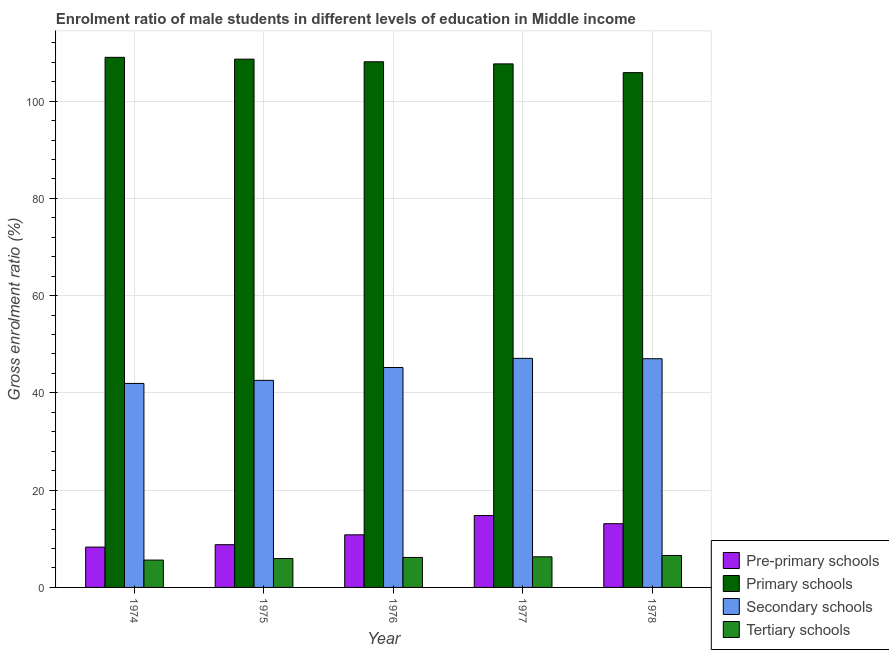How many different coloured bars are there?
Offer a very short reply. 4. How many groups of bars are there?
Provide a short and direct response. 5. Are the number of bars per tick equal to the number of legend labels?
Ensure brevity in your answer.  Yes. Are the number of bars on each tick of the X-axis equal?
Your response must be concise. Yes. How many bars are there on the 3rd tick from the left?
Make the answer very short. 4. How many bars are there on the 1st tick from the right?
Give a very brief answer. 4. What is the label of the 1st group of bars from the left?
Make the answer very short. 1974. In how many cases, is the number of bars for a given year not equal to the number of legend labels?
Your answer should be very brief. 0. What is the gross enrolment ratio(female) in primary schools in 1978?
Provide a succinct answer. 105.85. Across all years, what is the maximum gross enrolment ratio(female) in pre-primary schools?
Ensure brevity in your answer.  14.78. Across all years, what is the minimum gross enrolment ratio(female) in secondary schools?
Provide a short and direct response. 41.95. In which year was the gross enrolment ratio(female) in primary schools maximum?
Make the answer very short. 1974. In which year was the gross enrolment ratio(female) in primary schools minimum?
Your answer should be compact. 1978. What is the total gross enrolment ratio(female) in secondary schools in the graph?
Provide a succinct answer. 223.88. What is the difference between the gross enrolment ratio(female) in pre-primary schools in 1975 and that in 1977?
Make the answer very short. -5.99. What is the difference between the gross enrolment ratio(female) in secondary schools in 1976 and the gross enrolment ratio(female) in primary schools in 1978?
Provide a succinct answer. -1.81. What is the average gross enrolment ratio(female) in secondary schools per year?
Make the answer very short. 44.78. In the year 1976, what is the difference between the gross enrolment ratio(female) in secondary schools and gross enrolment ratio(female) in pre-primary schools?
Provide a short and direct response. 0. What is the ratio of the gross enrolment ratio(female) in tertiary schools in 1974 to that in 1977?
Offer a terse response. 0.89. Is the gross enrolment ratio(female) in secondary schools in 1974 less than that in 1978?
Make the answer very short. Yes. Is the difference between the gross enrolment ratio(female) in secondary schools in 1974 and 1976 greater than the difference between the gross enrolment ratio(female) in primary schools in 1974 and 1976?
Your answer should be very brief. No. What is the difference between the highest and the second highest gross enrolment ratio(female) in tertiary schools?
Keep it short and to the point. 0.28. What is the difference between the highest and the lowest gross enrolment ratio(female) in pre-primary schools?
Make the answer very short. 6.49. Is the sum of the gross enrolment ratio(female) in primary schools in 1974 and 1977 greater than the maximum gross enrolment ratio(female) in pre-primary schools across all years?
Offer a terse response. Yes. What does the 4th bar from the left in 1978 represents?
Provide a succinct answer. Tertiary schools. What does the 3rd bar from the right in 1978 represents?
Provide a succinct answer. Primary schools. Are all the bars in the graph horizontal?
Ensure brevity in your answer.  No. How many years are there in the graph?
Your answer should be very brief. 5. What is the difference between two consecutive major ticks on the Y-axis?
Provide a short and direct response. 20. Are the values on the major ticks of Y-axis written in scientific E-notation?
Provide a succinct answer. No. Does the graph contain grids?
Your answer should be compact. Yes. How are the legend labels stacked?
Your answer should be compact. Vertical. What is the title of the graph?
Your response must be concise. Enrolment ratio of male students in different levels of education in Middle income. Does "Terrestrial protected areas" appear as one of the legend labels in the graph?
Your answer should be very brief. No. What is the Gross enrolment ratio (%) in Pre-primary schools in 1974?
Keep it short and to the point. 8.29. What is the Gross enrolment ratio (%) in Primary schools in 1974?
Your response must be concise. 109. What is the Gross enrolment ratio (%) of Secondary schools in 1974?
Keep it short and to the point. 41.95. What is the Gross enrolment ratio (%) of Tertiary schools in 1974?
Offer a terse response. 5.62. What is the Gross enrolment ratio (%) in Pre-primary schools in 1975?
Ensure brevity in your answer.  8.79. What is the Gross enrolment ratio (%) in Primary schools in 1975?
Provide a succinct answer. 108.63. What is the Gross enrolment ratio (%) of Secondary schools in 1975?
Your response must be concise. 42.58. What is the Gross enrolment ratio (%) of Tertiary schools in 1975?
Provide a succinct answer. 5.94. What is the Gross enrolment ratio (%) in Pre-primary schools in 1976?
Provide a short and direct response. 10.82. What is the Gross enrolment ratio (%) in Primary schools in 1976?
Your answer should be very brief. 108.09. What is the Gross enrolment ratio (%) of Secondary schools in 1976?
Provide a short and direct response. 45.22. What is the Gross enrolment ratio (%) in Tertiary schools in 1976?
Your response must be concise. 6.17. What is the Gross enrolment ratio (%) in Pre-primary schools in 1977?
Offer a very short reply. 14.78. What is the Gross enrolment ratio (%) of Primary schools in 1977?
Offer a very short reply. 107.65. What is the Gross enrolment ratio (%) of Secondary schools in 1977?
Provide a succinct answer. 47.1. What is the Gross enrolment ratio (%) of Tertiary schools in 1977?
Your answer should be compact. 6.29. What is the Gross enrolment ratio (%) of Pre-primary schools in 1978?
Give a very brief answer. 13.1. What is the Gross enrolment ratio (%) in Primary schools in 1978?
Offer a terse response. 105.85. What is the Gross enrolment ratio (%) in Secondary schools in 1978?
Your answer should be compact. 47.03. What is the Gross enrolment ratio (%) in Tertiary schools in 1978?
Your answer should be very brief. 6.57. Across all years, what is the maximum Gross enrolment ratio (%) of Pre-primary schools?
Your answer should be compact. 14.78. Across all years, what is the maximum Gross enrolment ratio (%) in Primary schools?
Offer a terse response. 109. Across all years, what is the maximum Gross enrolment ratio (%) of Secondary schools?
Ensure brevity in your answer.  47.1. Across all years, what is the maximum Gross enrolment ratio (%) in Tertiary schools?
Make the answer very short. 6.57. Across all years, what is the minimum Gross enrolment ratio (%) of Pre-primary schools?
Make the answer very short. 8.29. Across all years, what is the minimum Gross enrolment ratio (%) in Primary schools?
Your answer should be compact. 105.85. Across all years, what is the minimum Gross enrolment ratio (%) in Secondary schools?
Your response must be concise. 41.95. Across all years, what is the minimum Gross enrolment ratio (%) of Tertiary schools?
Keep it short and to the point. 5.62. What is the total Gross enrolment ratio (%) of Pre-primary schools in the graph?
Your answer should be very brief. 55.79. What is the total Gross enrolment ratio (%) in Primary schools in the graph?
Provide a succinct answer. 539.21. What is the total Gross enrolment ratio (%) of Secondary schools in the graph?
Keep it short and to the point. 223.88. What is the total Gross enrolment ratio (%) in Tertiary schools in the graph?
Your answer should be compact. 30.6. What is the difference between the Gross enrolment ratio (%) in Pre-primary schools in 1974 and that in 1975?
Your answer should be very brief. -0.5. What is the difference between the Gross enrolment ratio (%) of Primary schools in 1974 and that in 1975?
Offer a terse response. 0.37. What is the difference between the Gross enrolment ratio (%) of Secondary schools in 1974 and that in 1975?
Your answer should be very brief. -0.63. What is the difference between the Gross enrolment ratio (%) in Tertiary schools in 1974 and that in 1975?
Offer a very short reply. -0.32. What is the difference between the Gross enrolment ratio (%) in Pre-primary schools in 1974 and that in 1976?
Ensure brevity in your answer.  -2.52. What is the difference between the Gross enrolment ratio (%) of Primary schools in 1974 and that in 1976?
Give a very brief answer. 0.91. What is the difference between the Gross enrolment ratio (%) of Secondary schools in 1974 and that in 1976?
Keep it short and to the point. -3.28. What is the difference between the Gross enrolment ratio (%) in Tertiary schools in 1974 and that in 1976?
Offer a terse response. -0.54. What is the difference between the Gross enrolment ratio (%) of Pre-primary schools in 1974 and that in 1977?
Provide a succinct answer. -6.49. What is the difference between the Gross enrolment ratio (%) in Primary schools in 1974 and that in 1977?
Your answer should be compact. 1.35. What is the difference between the Gross enrolment ratio (%) in Secondary schools in 1974 and that in 1977?
Your answer should be compact. -5.16. What is the difference between the Gross enrolment ratio (%) in Tertiary schools in 1974 and that in 1977?
Keep it short and to the point. -0.67. What is the difference between the Gross enrolment ratio (%) in Pre-primary schools in 1974 and that in 1978?
Your answer should be very brief. -4.81. What is the difference between the Gross enrolment ratio (%) in Primary schools in 1974 and that in 1978?
Provide a short and direct response. 3.15. What is the difference between the Gross enrolment ratio (%) in Secondary schools in 1974 and that in 1978?
Give a very brief answer. -5.08. What is the difference between the Gross enrolment ratio (%) in Tertiary schools in 1974 and that in 1978?
Give a very brief answer. -0.95. What is the difference between the Gross enrolment ratio (%) of Pre-primary schools in 1975 and that in 1976?
Offer a very short reply. -2.03. What is the difference between the Gross enrolment ratio (%) in Primary schools in 1975 and that in 1976?
Ensure brevity in your answer.  0.54. What is the difference between the Gross enrolment ratio (%) of Secondary schools in 1975 and that in 1976?
Give a very brief answer. -2.64. What is the difference between the Gross enrolment ratio (%) of Tertiary schools in 1975 and that in 1976?
Provide a succinct answer. -0.23. What is the difference between the Gross enrolment ratio (%) of Pre-primary schools in 1975 and that in 1977?
Offer a very short reply. -5.99. What is the difference between the Gross enrolment ratio (%) in Primary schools in 1975 and that in 1977?
Your answer should be compact. 0.97. What is the difference between the Gross enrolment ratio (%) of Secondary schools in 1975 and that in 1977?
Offer a terse response. -4.52. What is the difference between the Gross enrolment ratio (%) in Tertiary schools in 1975 and that in 1977?
Your answer should be compact. -0.36. What is the difference between the Gross enrolment ratio (%) of Pre-primary schools in 1975 and that in 1978?
Keep it short and to the point. -4.31. What is the difference between the Gross enrolment ratio (%) of Primary schools in 1975 and that in 1978?
Your answer should be compact. 2.78. What is the difference between the Gross enrolment ratio (%) in Secondary schools in 1975 and that in 1978?
Offer a very short reply. -4.45. What is the difference between the Gross enrolment ratio (%) of Tertiary schools in 1975 and that in 1978?
Provide a short and direct response. -0.63. What is the difference between the Gross enrolment ratio (%) in Pre-primary schools in 1976 and that in 1977?
Provide a short and direct response. -3.97. What is the difference between the Gross enrolment ratio (%) of Primary schools in 1976 and that in 1977?
Your answer should be very brief. 0.43. What is the difference between the Gross enrolment ratio (%) in Secondary schools in 1976 and that in 1977?
Give a very brief answer. -1.88. What is the difference between the Gross enrolment ratio (%) in Tertiary schools in 1976 and that in 1977?
Your response must be concise. -0.13. What is the difference between the Gross enrolment ratio (%) in Pre-primary schools in 1976 and that in 1978?
Provide a short and direct response. -2.28. What is the difference between the Gross enrolment ratio (%) in Primary schools in 1976 and that in 1978?
Provide a succinct answer. 2.23. What is the difference between the Gross enrolment ratio (%) in Secondary schools in 1976 and that in 1978?
Offer a terse response. -1.81. What is the difference between the Gross enrolment ratio (%) in Tertiary schools in 1976 and that in 1978?
Your answer should be compact. -0.41. What is the difference between the Gross enrolment ratio (%) in Pre-primary schools in 1977 and that in 1978?
Provide a short and direct response. 1.68. What is the difference between the Gross enrolment ratio (%) of Primary schools in 1977 and that in 1978?
Offer a very short reply. 1.8. What is the difference between the Gross enrolment ratio (%) of Secondary schools in 1977 and that in 1978?
Offer a terse response. 0.08. What is the difference between the Gross enrolment ratio (%) of Tertiary schools in 1977 and that in 1978?
Provide a succinct answer. -0.28. What is the difference between the Gross enrolment ratio (%) of Pre-primary schools in 1974 and the Gross enrolment ratio (%) of Primary schools in 1975?
Make the answer very short. -100.33. What is the difference between the Gross enrolment ratio (%) of Pre-primary schools in 1974 and the Gross enrolment ratio (%) of Secondary schools in 1975?
Provide a succinct answer. -34.29. What is the difference between the Gross enrolment ratio (%) in Pre-primary schools in 1974 and the Gross enrolment ratio (%) in Tertiary schools in 1975?
Ensure brevity in your answer.  2.35. What is the difference between the Gross enrolment ratio (%) of Primary schools in 1974 and the Gross enrolment ratio (%) of Secondary schools in 1975?
Make the answer very short. 66.42. What is the difference between the Gross enrolment ratio (%) of Primary schools in 1974 and the Gross enrolment ratio (%) of Tertiary schools in 1975?
Your answer should be compact. 103.06. What is the difference between the Gross enrolment ratio (%) of Secondary schools in 1974 and the Gross enrolment ratio (%) of Tertiary schools in 1975?
Your answer should be very brief. 36.01. What is the difference between the Gross enrolment ratio (%) of Pre-primary schools in 1974 and the Gross enrolment ratio (%) of Primary schools in 1976?
Offer a terse response. -99.79. What is the difference between the Gross enrolment ratio (%) of Pre-primary schools in 1974 and the Gross enrolment ratio (%) of Secondary schools in 1976?
Provide a short and direct response. -36.93. What is the difference between the Gross enrolment ratio (%) in Pre-primary schools in 1974 and the Gross enrolment ratio (%) in Tertiary schools in 1976?
Offer a very short reply. 2.13. What is the difference between the Gross enrolment ratio (%) of Primary schools in 1974 and the Gross enrolment ratio (%) of Secondary schools in 1976?
Make the answer very short. 63.78. What is the difference between the Gross enrolment ratio (%) of Primary schools in 1974 and the Gross enrolment ratio (%) of Tertiary schools in 1976?
Provide a short and direct response. 102.83. What is the difference between the Gross enrolment ratio (%) of Secondary schools in 1974 and the Gross enrolment ratio (%) of Tertiary schools in 1976?
Provide a succinct answer. 35.78. What is the difference between the Gross enrolment ratio (%) of Pre-primary schools in 1974 and the Gross enrolment ratio (%) of Primary schools in 1977?
Your response must be concise. -99.36. What is the difference between the Gross enrolment ratio (%) in Pre-primary schools in 1974 and the Gross enrolment ratio (%) in Secondary schools in 1977?
Ensure brevity in your answer.  -38.81. What is the difference between the Gross enrolment ratio (%) in Pre-primary schools in 1974 and the Gross enrolment ratio (%) in Tertiary schools in 1977?
Offer a terse response. 2. What is the difference between the Gross enrolment ratio (%) of Primary schools in 1974 and the Gross enrolment ratio (%) of Secondary schools in 1977?
Your response must be concise. 61.9. What is the difference between the Gross enrolment ratio (%) of Primary schools in 1974 and the Gross enrolment ratio (%) of Tertiary schools in 1977?
Provide a succinct answer. 102.71. What is the difference between the Gross enrolment ratio (%) in Secondary schools in 1974 and the Gross enrolment ratio (%) in Tertiary schools in 1977?
Provide a succinct answer. 35.65. What is the difference between the Gross enrolment ratio (%) of Pre-primary schools in 1974 and the Gross enrolment ratio (%) of Primary schools in 1978?
Give a very brief answer. -97.56. What is the difference between the Gross enrolment ratio (%) in Pre-primary schools in 1974 and the Gross enrolment ratio (%) in Secondary schools in 1978?
Keep it short and to the point. -38.73. What is the difference between the Gross enrolment ratio (%) in Pre-primary schools in 1974 and the Gross enrolment ratio (%) in Tertiary schools in 1978?
Provide a succinct answer. 1.72. What is the difference between the Gross enrolment ratio (%) of Primary schools in 1974 and the Gross enrolment ratio (%) of Secondary schools in 1978?
Your answer should be very brief. 61.97. What is the difference between the Gross enrolment ratio (%) of Primary schools in 1974 and the Gross enrolment ratio (%) of Tertiary schools in 1978?
Your answer should be very brief. 102.43. What is the difference between the Gross enrolment ratio (%) in Secondary schools in 1974 and the Gross enrolment ratio (%) in Tertiary schools in 1978?
Your answer should be compact. 35.37. What is the difference between the Gross enrolment ratio (%) in Pre-primary schools in 1975 and the Gross enrolment ratio (%) in Primary schools in 1976?
Ensure brevity in your answer.  -99.29. What is the difference between the Gross enrolment ratio (%) in Pre-primary schools in 1975 and the Gross enrolment ratio (%) in Secondary schools in 1976?
Give a very brief answer. -36.43. What is the difference between the Gross enrolment ratio (%) of Pre-primary schools in 1975 and the Gross enrolment ratio (%) of Tertiary schools in 1976?
Give a very brief answer. 2.62. What is the difference between the Gross enrolment ratio (%) in Primary schools in 1975 and the Gross enrolment ratio (%) in Secondary schools in 1976?
Your response must be concise. 63.41. What is the difference between the Gross enrolment ratio (%) in Primary schools in 1975 and the Gross enrolment ratio (%) in Tertiary schools in 1976?
Provide a short and direct response. 102.46. What is the difference between the Gross enrolment ratio (%) of Secondary schools in 1975 and the Gross enrolment ratio (%) of Tertiary schools in 1976?
Keep it short and to the point. 36.41. What is the difference between the Gross enrolment ratio (%) of Pre-primary schools in 1975 and the Gross enrolment ratio (%) of Primary schools in 1977?
Provide a short and direct response. -98.86. What is the difference between the Gross enrolment ratio (%) in Pre-primary schools in 1975 and the Gross enrolment ratio (%) in Secondary schools in 1977?
Ensure brevity in your answer.  -38.31. What is the difference between the Gross enrolment ratio (%) in Pre-primary schools in 1975 and the Gross enrolment ratio (%) in Tertiary schools in 1977?
Provide a short and direct response. 2.5. What is the difference between the Gross enrolment ratio (%) of Primary schools in 1975 and the Gross enrolment ratio (%) of Secondary schools in 1977?
Your answer should be compact. 61.52. What is the difference between the Gross enrolment ratio (%) of Primary schools in 1975 and the Gross enrolment ratio (%) of Tertiary schools in 1977?
Your response must be concise. 102.33. What is the difference between the Gross enrolment ratio (%) in Secondary schools in 1975 and the Gross enrolment ratio (%) in Tertiary schools in 1977?
Provide a succinct answer. 36.29. What is the difference between the Gross enrolment ratio (%) of Pre-primary schools in 1975 and the Gross enrolment ratio (%) of Primary schools in 1978?
Keep it short and to the point. -97.06. What is the difference between the Gross enrolment ratio (%) in Pre-primary schools in 1975 and the Gross enrolment ratio (%) in Secondary schools in 1978?
Ensure brevity in your answer.  -38.24. What is the difference between the Gross enrolment ratio (%) of Pre-primary schools in 1975 and the Gross enrolment ratio (%) of Tertiary schools in 1978?
Offer a very short reply. 2.22. What is the difference between the Gross enrolment ratio (%) in Primary schools in 1975 and the Gross enrolment ratio (%) in Secondary schools in 1978?
Provide a succinct answer. 61.6. What is the difference between the Gross enrolment ratio (%) of Primary schools in 1975 and the Gross enrolment ratio (%) of Tertiary schools in 1978?
Provide a short and direct response. 102.05. What is the difference between the Gross enrolment ratio (%) in Secondary schools in 1975 and the Gross enrolment ratio (%) in Tertiary schools in 1978?
Ensure brevity in your answer.  36.01. What is the difference between the Gross enrolment ratio (%) in Pre-primary schools in 1976 and the Gross enrolment ratio (%) in Primary schools in 1977?
Provide a succinct answer. -96.83. What is the difference between the Gross enrolment ratio (%) in Pre-primary schools in 1976 and the Gross enrolment ratio (%) in Secondary schools in 1977?
Give a very brief answer. -36.29. What is the difference between the Gross enrolment ratio (%) of Pre-primary schools in 1976 and the Gross enrolment ratio (%) of Tertiary schools in 1977?
Ensure brevity in your answer.  4.52. What is the difference between the Gross enrolment ratio (%) in Primary schools in 1976 and the Gross enrolment ratio (%) in Secondary schools in 1977?
Keep it short and to the point. 60.98. What is the difference between the Gross enrolment ratio (%) in Primary schools in 1976 and the Gross enrolment ratio (%) in Tertiary schools in 1977?
Offer a terse response. 101.79. What is the difference between the Gross enrolment ratio (%) of Secondary schools in 1976 and the Gross enrolment ratio (%) of Tertiary schools in 1977?
Provide a short and direct response. 38.93. What is the difference between the Gross enrolment ratio (%) of Pre-primary schools in 1976 and the Gross enrolment ratio (%) of Primary schools in 1978?
Offer a terse response. -95.03. What is the difference between the Gross enrolment ratio (%) of Pre-primary schools in 1976 and the Gross enrolment ratio (%) of Secondary schools in 1978?
Keep it short and to the point. -36.21. What is the difference between the Gross enrolment ratio (%) of Pre-primary schools in 1976 and the Gross enrolment ratio (%) of Tertiary schools in 1978?
Your answer should be very brief. 4.24. What is the difference between the Gross enrolment ratio (%) in Primary schools in 1976 and the Gross enrolment ratio (%) in Secondary schools in 1978?
Your answer should be compact. 61.06. What is the difference between the Gross enrolment ratio (%) of Primary schools in 1976 and the Gross enrolment ratio (%) of Tertiary schools in 1978?
Make the answer very short. 101.51. What is the difference between the Gross enrolment ratio (%) in Secondary schools in 1976 and the Gross enrolment ratio (%) in Tertiary schools in 1978?
Your answer should be compact. 38.65. What is the difference between the Gross enrolment ratio (%) in Pre-primary schools in 1977 and the Gross enrolment ratio (%) in Primary schools in 1978?
Offer a terse response. -91.07. What is the difference between the Gross enrolment ratio (%) of Pre-primary schools in 1977 and the Gross enrolment ratio (%) of Secondary schools in 1978?
Offer a terse response. -32.24. What is the difference between the Gross enrolment ratio (%) of Pre-primary schools in 1977 and the Gross enrolment ratio (%) of Tertiary schools in 1978?
Your answer should be compact. 8.21. What is the difference between the Gross enrolment ratio (%) in Primary schools in 1977 and the Gross enrolment ratio (%) in Secondary schools in 1978?
Keep it short and to the point. 60.63. What is the difference between the Gross enrolment ratio (%) in Primary schools in 1977 and the Gross enrolment ratio (%) in Tertiary schools in 1978?
Provide a short and direct response. 101.08. What is the difference between the Gross enrolment ratio (%) of Secondary schools in 1977 and the Gross enrolment ratio (%) of Tertiary schools in 1978?
Offer a terse response. 40.53. What is the average Gross enrolment ratio (%) in Pre-primary schools per year?
Offer a very short reply. 11.16. What is the average Gross enrolment ratio (%) of Primary schools per year?
Keep it short and to the point. 107.84. What is the average Gross enrolment ratio (%) of Secondary schools per year?
Ensure brevity in your answer.  44.78. What is the average Gross enrolment ratio (%) in Tertiary schools per year?
Provide a short and direct response. 6.12. In the year 1974, what is the difference between the Gross enrolment ratio (%) in Pre-primary schools and Gross enrolment ratio (%) in Primary schools?
Your answer should be compact. -100.71. In the year 1974, what is the difference between the Gross enrolment ratio (%) of Pre-primary schools and Gross enrolment ratio (%) of Secondary schools?
Keep it short and to the point. -33.65. In the year 1974, what is the difference between the Gross enrolment ratio (%) in Pre-primary schools and Gross enrolment ratio (%) in Tertiary schools?
Make the answer very short. 2.67. In the year 1974, what is the difference between the Gross enrolment ratio (%) of Primary schools and Gross enrolment ratio (%) of Secondary schools?
Provide a succinct answer. 67.05. In the year 1974, what is the difference between the Gross enrolment ratio (%) of Primary schools and Gross enrolment ratio (%) of Tertiary schools?
Make the answer very short. 103.38. In the year 1974, what is the difference between the Gross enrolment ratio (%) of Secondary schools and Gross enrolment ratio (%) of Tertiary schools?
Make the answer very short. 36.32. In the year 1975, what is the difference between the Gross enrolment ratio (%) in Pre-primary schools and Gross enrolment ratio (%) in Primary schools?
Provide a succinct answer. -99.84. In the year 1975, what is the difference between the Gross enrolment ratio (%) in Pre-primary schools and Gross enrolment ratio (%) in Secondary schools?
Provide a succinct answer. -33.79. In the year 1975, what is the difference between the Gross enrolment ratio (%) of Pre-primary schools and Gross enrolment ratio (%) of Tertiary schools?
Ensure brevity in your answer.  2.85. In the year 1975, what is the difference between the Gross enrolment ratio (%) in Primary schools and Gross enrolment ratio (%) in Secondary schools?
Ensure brevity in your answer.  66.05. In the year 1975, what is the difference between the Gross enrolment ratio (%) of Primary schools and Gross enrolment ratio (%) of Tertiary schools?
Give a very brief answer. 102.69. In the year 1975, what is the difference between the Gross enrolment ratio (%) in Secondary schools and Gross enrolment ratio (%) in Tertiary schools?
Your answer should be compact. 36.64. In the year 1976, what is the difference between the Gross enrolment ratio (%) in Pre-primary schools and Gross enrolment ratio (%) in Primary schools?
Your answer should be very brief. -97.27. In the year 1976, what is the difference between the Gross enrolment ratio (%) of Pre-primary schools and Gross enrolment ratio (%) of Secondary schools?
Keep it short and to the point. -34.4. In the year 1976, what is the difference between the Gross enrolment ratio (%) of Pre-primary schools and Gross enrolment ratio (%) of Tertiary schools?
Your answer should be compact. 4.65. In the year 1976, what is the difference between the Gross enrolment ratio (%) of Primary schools and Gross enrolment ratio (%) of Secondary schools?
Offer a terse response. 62.86. In the year 1976, what is the difference between the Gross enrolment ratio (%) in Primary schools and Gross enrolment ratio (%) in Tertiary schools?
Ensure brevity in your answer.  101.92. In the year 1976, what is the difference between the Gross enrolment ratio (%) of Secondary schools and Gross enrolment ratio (%) of Tertiary schools?
Your response must be concise. 39.06. In the year 1977, what is the difference between the Gross enrolment ratio (%) of Pre-primary schools and Gross enrolment ratio (%) of Primary schools?
Keep it short and to the point. -92.87. In the year 1977, what is the difference between the Gross enrolment ratio (%) in Pre-primary schools and Gross enrolment ratio (%) in Secondary schools?
Your answer should be very brief. -32.32. In the year 1977, what is the difference between the Gross enrolment ratio (%) of Pre-primary schools and Gross enrolment ratio (%) of Tertiary schools?
Provide a short and direct response. 8.49. In the year 1977, what is the difference between the Gross enrolment ratio (%) of Primary schools and Gross enrolment ratio (%) of Secondary schools?
Your answer should be compact. 60.55. In the year 1977, what is the difference between the Gross enrolment ratio (%) in Primary schools and Gross enrolment ratio (%) in Tertiary schools?
Give a very brief answer. 101.36. In the year 1977, what is the difference between the Gross enrolment ratio (%) in Secondary schools and Gross enrolment ratio (%) in Tertiary schools?
Give a very brief answer. 40.81. In the year 1978, what is the difference between the Gross enrolment ratio (%) in Pre-primary schools and Gross enrolment ratio (%) in Primary schools?
Give a very brief answer. -92.75. In the year 1978, what is the difference between the Gross enrolment ratio (%) in Pre-primary schools and Gross enrolment ratio (%) in Secondary schools?
Provide a succinct answer. -33.93. In the year 1978, what is the difference between the Gross enrolment ratio (%) in Pre-primary schools and Gross enrolment ratio (%) in Tertiary schools?
Ensure brevity in your answer.  6.53. In the year 1978, what is the difference between the Gross enrolment ratio (%) of Primary schools and Gross enrolment ratio (%) of Secondary schools?
Make the answer very short. 58.82. In the year 1978, what is the difference between the Gross enrolment ratio (%) in Primary schools and Gross enrolment ratio (%) in Tertiary schools?
Offer a very short reply. 99.28. In the year 1978, what is the difference between the Gross enrolment ratio (%) in Secondary schools and Gross enrolment ratio (%) in Tertiary schools?
Ensure brevity in your answer.  40.45. What is the ratio of the Gross enrolment ratio (%) in Pre-primary schools in 1974 to that in 1975?
Your response must be concise. 0.94. What is the ratio of the Gross enrolment ratio (%) in Primary schools in 1974 to that in 1975?
Your answer should be compact. 1. What is the ratio of the Gross enrolment ratio (%) in Secondary schools in 1974 to that in 1975?
Provide a short and direct response. 0.99. What is the ratio of the Gross enrolment ratio (%) in Tertiary schools in 1974 to that in 1975?
Make the answer very short. 0.95. What is the ratio of the Gross enrolment ratio (%) in Pre-primary schools in 1974 to that in 1976?
Offer a terse response. 0.77. What is the ratio of the Gross enrolment ratio (%) in Primary schools in 1974 to that in 1976?
Keep it short and to the point. 1.01. What is the ratio of the Gross enrolment ratio (%) of Secondary schools in 1974 to that in 1976?
Offer a very short reply. 0.93. What is the ratio of the Gross enrolment ratio (%) of Tertiary schools in 1974 to that in 1976?
Make the answer very short. 0.91. What is the ratio of the Gross enrolment ratio (%) in Pre-primary schools in 1974 to that in 1977?
Keep it short and to the point. 0.56. What is the ratio of the Gross enrolment ratio (%) in Primary schools in 1974 to that in 1977?
Provide a short and direct response. 1.01. What is the ratio of the Gross enrolment ratio (%) in Secondary schools in 1974 to that in 1977?
Your answer should be compact. 0.89. What is the ratio of the Gross enrolment ratio (%) of Tertiary schools in 1974 to that in 1977?
Provide a succinct answer. 0.89. What is the ratio of the Gross enrolment ratio (%) of Pre-primary schools in 1974 to that in 1978?
Give a very brief answer. 0.63. What is the ratio of the Gross enrolment ratio (%) of Primary schools in 1974 to that in 1978?
Provide a succinct answer. 1.03. What is the ratio of the Gross enrolment ratio (%) in Secondary schools in 1974 to that in 1978?
Your response must be concise. 0.89. What is the ratio of the Gross enrolment ratio (%) of Tertiary schools in 1974 to that in 1978?
Make the answer very short. 0.86. What is the ratio of the Gross enrolment ratio (%) in Pre-primary schools in 1975 to that in 1976?
Your response must be concise. 0.81. What is the ratio of the Gross enrolment ratio (%) of Primary schools in 1975 to that in 1976?
Give a very brief answer. 1. What is the ratio of the Gross enrolment ratio (%) in Secondary schools in 1975 to that in 1976?
Provide a short and direct response. 0.94. What is the ratio of the Gross enrolment ratio (%) in Tertiary schools in 1975 to that in 1976?
Give a very brief answer. 0.96. What is the ratio of the Gross enrolment ratio (%) of Pre-primary schools in 1975 to that in 1977?
Your answer should be very brief. 0.59. What is the ratio of the Gross enrolment ratio (%) of Primary schools in 1975 to that in 1977?
Offer a terse response. 1.01. What is the ratio of the Gross enrolment ratio (%) in Secondary schools in 1975 to that in 1977?
Your answer should be compact. 0.9. What is the ratio of the Gross enrolment ratio (%) of Tertiary schools in 1975 to that in 1977?
Ensure brevity in your answer.  0.94. What is the ratio of the Gross enrolment ratio (%) of Pre-primary schools in 1975 to that in 1978?
Your response must be concise. 0.67. What is the ratio of the Gross enrolment ratio (%) in Primary schools in 1975 to that in 1978?
Your answer should be very brief. 1.03. What is the ratio of the Gross enrolment ratio (%) in Secondary schools in 1975 to that in 1978?
Offer a terse response. 0.91. What is the ratio of the Gross enrolment ratio (%) in Tertiary schools in 1975 to that in 1978?
Provide a short and direct response. 0.9. What is the ratio of the Gross enrolment ratio (%) of Pre-primary schools in 1976 to that in 1977?
Provide a succinct answer. 0.73. What is the ratio of the Gross enrolment ratio (%) in Primary schools in 1976 to that in 1977?
Ensure brevity in your answer.  1. What is the ratio of the Gross enrolment ratio (%) in Tertiary schools in 1976 to that in 1977?
Your response must be concise. 0.98. What is the ratio of the Gross enrolment ratio (%) in Pre-primary schools in 1976 to that in 1978?
Your answer should be very brief. 0.83. What is the ratio of the Gross enrolment ratio (%) in Primary schools in 1976 to that in 1978?
Offer a terse response. 1.02. What is the ratio of the Gross enrolment ratio (%) in Secondary schools in 1976 to that in 1978?
Make the answer very short. 0.96. What is the ratio of the Gross enrolment ratio (%) of Tertiary schools in 1976 to that in 1978?
Your answer should be very brief. 0.94. What is the ratio of the Gross enrolment ratio (%) of Pre-primary schools in 1977 to that in 1978?
Keep it short and to the point. 1.13. What is the ratio of the Gross enrolment ratio (%) in Primary schools in 1977 to that in 1978?
Make the answer very short. 1.02. What is the ratio of the Gross enrolment ratio (%) in Secondary schools in 1977 to that in 1978?
Your answer should be very brief. 1. What is the ratio of the Gross enrolment ratio (%) in Tertiary schools in 1977 to that in 1978?
Provide a succinct answer. 0.96. What is the difference between the highest and the second highest Gross enrolment ratio (%) in Pre-primary schools?
Offer a terse response. 1.68. What is the difference between the highest and the second highest Gross enrolment ratio (%) in Primary schools?
Your answer should be compact. 0.37. What is the difference between the highest and the second highest Gross enrolment ratio (%) of Secondary schools?
Ensure brevity in your answer.  0.08. What is the difference between the highest and the second highest Gross enrolment ratio (%) in Tertiary schools?
Offer a terse response. 0.28. What is the difference between the highest and the lowest Gross enrolment ratio (%) of Pre-primary schools?
Provide a short and direct response. 6.49. What is the difference between the highest and the lowest Gross enrolment ratio (%) of Primary schools?
Your answer should be compact. 3.15. What is the difference between the highest and the lowest Gross enrolment ratio (%) in Secondary schools?
Your answer should be compact. 5.16. What is the difference between the highest and the lowest Gross enrolment ratio (%) of Tertiary schools?
Your response must be concise. 0.95. 